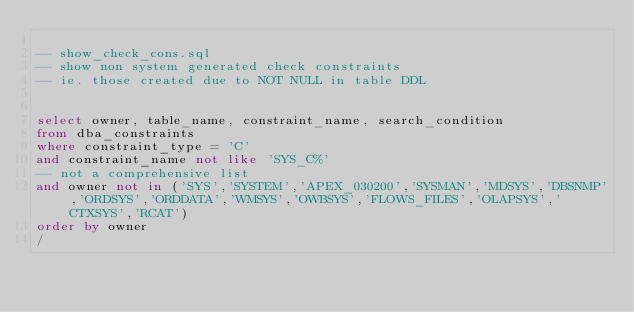<code> <loc_0><loc_0><loc_500><loc_500><_SQL_>
-- show_check_cons.sql
-- show non system generated check constraints
-- ie. those created due to NOT NULL in table DDL


select owner, table_name, constraint_name, search_condition
from dba_constraints
where constraint_type = 'C'
and constraint_name not like 'SYS_C%'
-- not a comprehensive list
and owner not in ('SYS','SYSTEM','APEX_030200','SYSMAN','MDSYS','DBSNMP','ORDSYS','ORDDATA','WMSYS','OWBSYS','FLOWS_FILES','OLAPSYS','CTXSYS','RCAT')
order by owner
/
</code> 